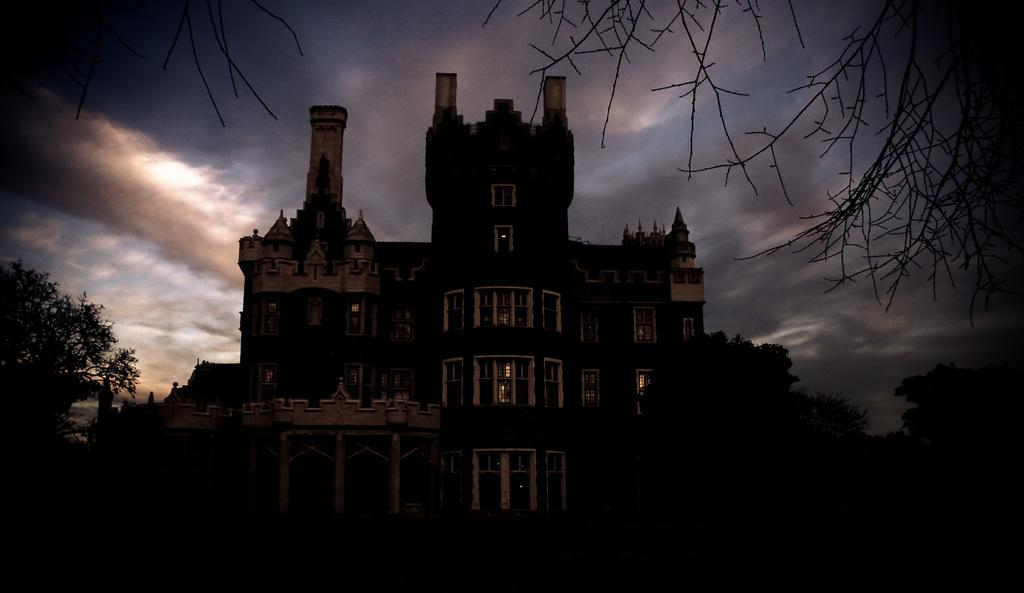What type of structure is visible in the image? There is a building in the image. What feature can be seen on the building? The building has windows. What type of vegetation is present in the image? There are trees in the image. What can be seen in the background of the image? The sky is visible in the background of the image. What is the condition of the sky in the image? Clouds are present in the sky. Can you tell me how many wishes are granted in the image? There are no wishes present in the image; it features a building, trees, and a sky with clouds. Is there any snow visible in the image? There is no snow present in the image; the sky is clear with clouds. 